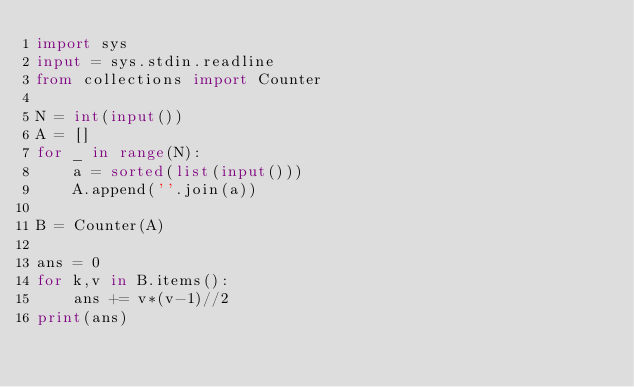<code> <loc_0><loc_0><loc_500><loc_500><_Python_>import sys
input = sys.stdin.readline
from collections import Counter

N = int(input())
A = []
for _ in range(N):
    a = sorted(list(input()))
    A.append(''.join(a))

B = Counter(A)

ans = 0
for k,v in B.items():
    ans += v*(v-1)//2
print(ans)</code> 